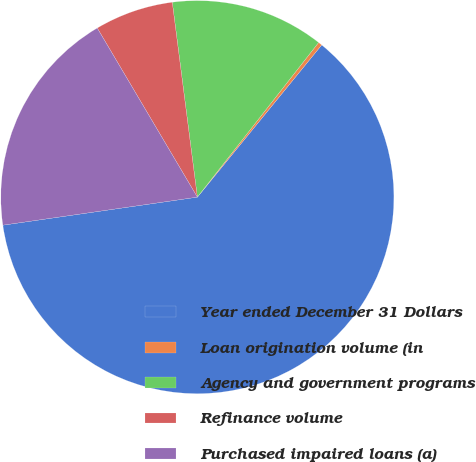<chart> <loc_0><loc_0><loc_500><loc_500><pie_chart><fcel>Year ended December 31 Dollars<fcel>Loan origination volume (in<fcel>Agency and government programs<fcel>Refinance volume<fcel>Purchased impaired loans (a)<nl><fcel>61.81%<fcel>0.32%<fcel>12.62%<fcel>6.47%<fcel>18.77%<nl></chart> 